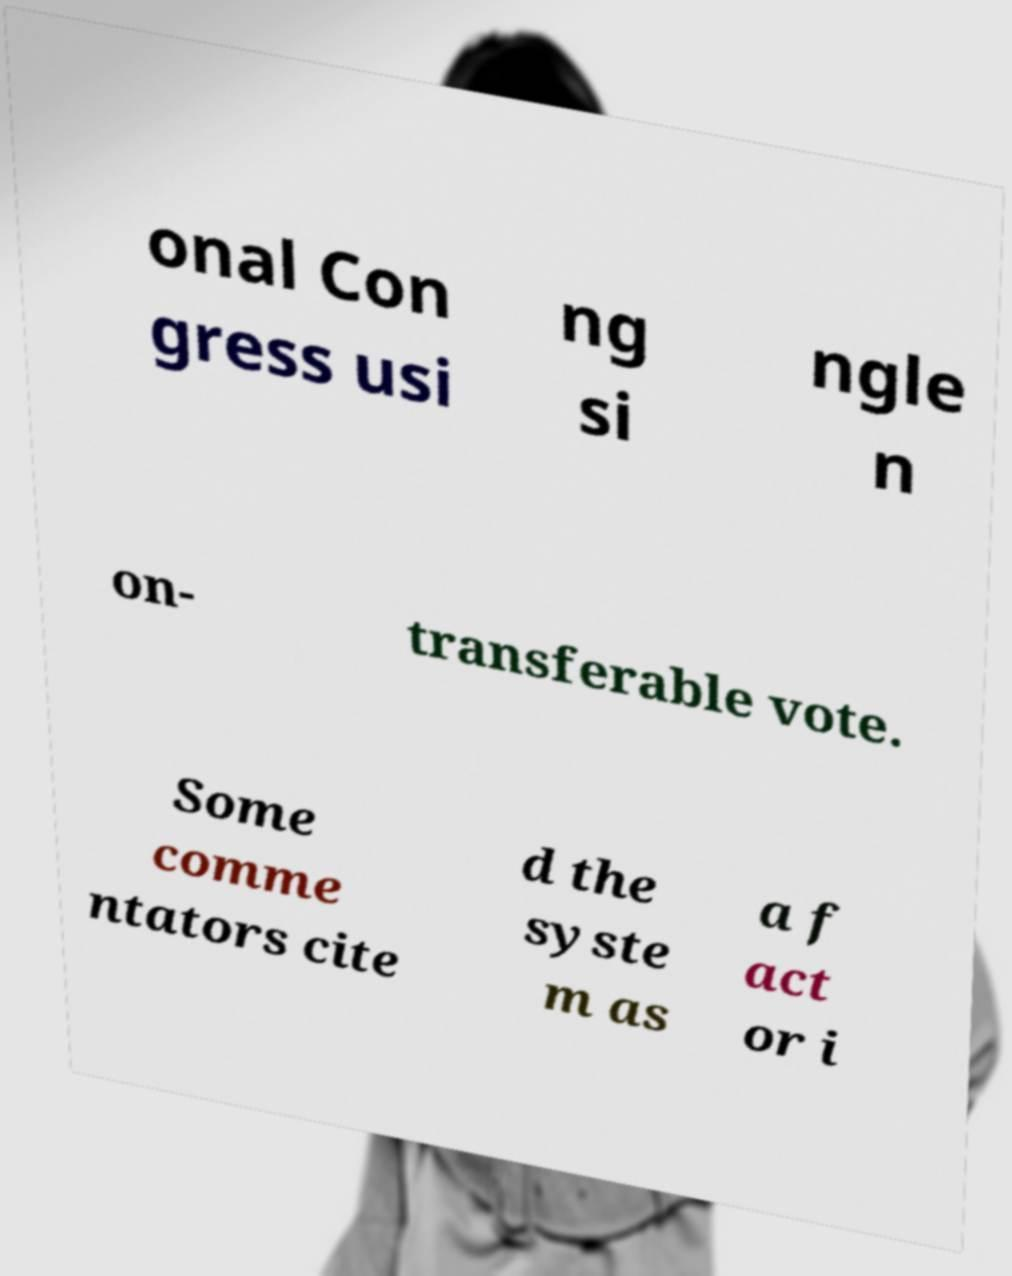Can you accurately transcribe the text from the provided image for me? onal Con gress usi ng si ngle n on- transferable vote. Some comme ntators cite d the syste m as a f act or i 